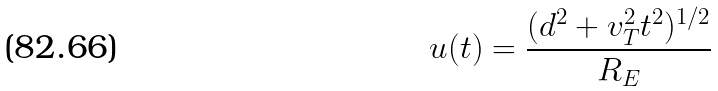<formula> <loc_0><loc_0><loc_500><loc_500>u ( t ) = \frac { ( d ^ { 2 } + v ^ { 2 } _ { T } t ^ { 2 } ) ^ { 1 / 2 } } { R _ { E } }</formula> 